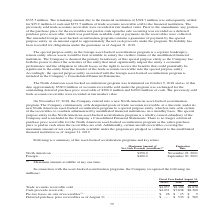From Jabil Circuit's financial document, Which years does the table provide data for trade accounts receivable sold? The document contains multiple relevant values: 2019, 2018, 2017. From the document: "Fiscal Year Ended August 31, 2019 (3) 2018 2017 obligations under the guarantee as of August 31, 2019. curitization program was terminated on October ..." Also, What were the cash proceeds received in 2019? According to the financial document, $4,031 (in millions). The relevant text states: "$4,057 $8,386 $8,878 Cash proceeds received (1) . $4,031 $7,838 $8,300 Pre-tax losses on sale of receivables (2) . $ 26 $ 15 $ 9 Deferred purchase price rece..." Also, What were the Pre-tax losses on sale of receivables in 2018? According to the financial document, $15 (in millions). The relevant text states: "re-tax losses on sale of receivables (2) . $ 26 $ 15 $ 9 Deferred purchase price receivables as of August 31 . $ — $ 533 $ 569..." Also, can you calculate: What was the change in Trade accounts receivable sold between 2018 and 2019? Based on the calculation: $4,057-$8,386, the result is -4329 (in millions). This is based on the information: "Trade accounts receivable sold . $4,057 $8,386 $8,878 Cash proceeds received (1) . $4,031 $7,838 $8,300 Pre-tax losses on sale of receivables (2) Trade accounts receivable sold . $4,057 $8,386 $8,878 ..." The key data points involved are: 4,057, 8,386. Also, How many years did cash proceeds received exceed $5,000 million? Counting the relevant items in the document: 2018, 2017, I find 2 instances. The key data points involved are: 2017, 2018. Also, can you calculate: What was the percentage change in Pre-tax losses on sale of receivables between 2017 and 2018? To answer this question, I need to perform calculations using the financial data. The calculation is: ($15-$9)/$9, which equals 66.67 (percentage). This is based on the information: "ning amount due to the financial institution of $398.7 million was subsequently settled for $25.2 million of cash and $373.5 million of trade accounts re-tax losses on sale of receivables (2) . $ 26 $..." The key data points involved are: 15, 9. 